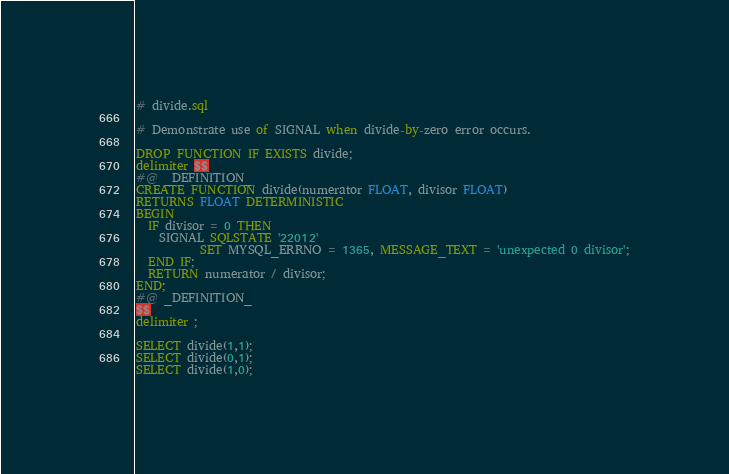<code> <loc_0><loc_0><loc_500><loc_500><_SQL_># divide.sql

# Demonstrate use of SIGNAL when divide-by-zero error occurs.

DROP FUNCTION IF EXISTS divide;
delimiter $$
#@ _DEFINITION_
CREATE FUNCTION divide(numerator FLOAT, divisor FLOAT)
RETURNS FLOAT DETERMINISTIC
BEGIN
  IF divisor = 0 THEN
    SIGNAL SQLSTATE '22012'
           SET MYSQL_ERRNO = 1365, MESSAGE_TEXT = 'unexpected 0 divisor';
  END IF;
  RETURN numerator / divisor;
END;
#@ _DEFINITION_
$$
delimiter ;

SELECT divide(1,1);
SELECT divide(0,1);
SELECT divide(1,0);
</code> 